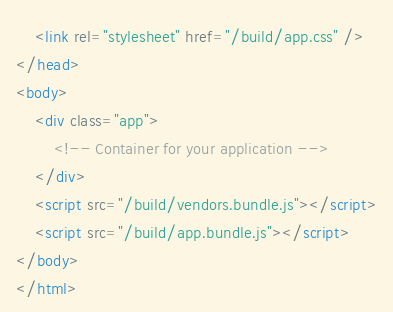Convert code to text. <code><loc_0><loc_0><loc_500><loc_500><_HTML_>    <link rel="stylesheet" href="/build/app.css" />
</head>
<body>
    <div class="app">
        <!-- Container for your application -->
    </div>
    <script src="/build/vendors.bundle.js"></script>
    <script src="/build/app.bundle.js"></script>
</body>
</html>
</code> 